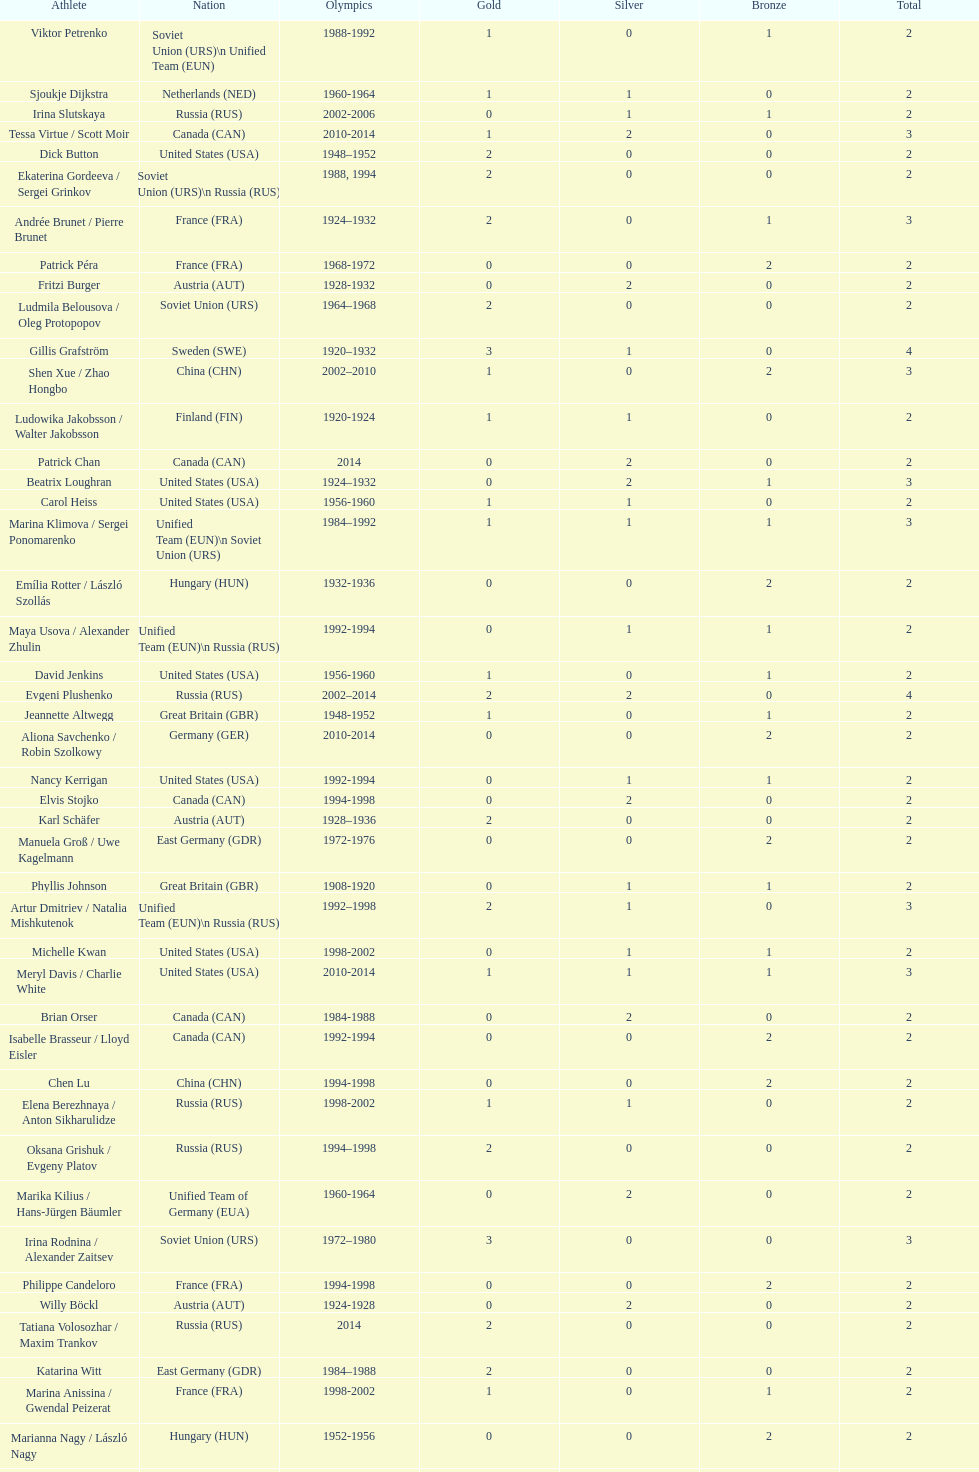How many medals have sweden and norway won combined? 7. 